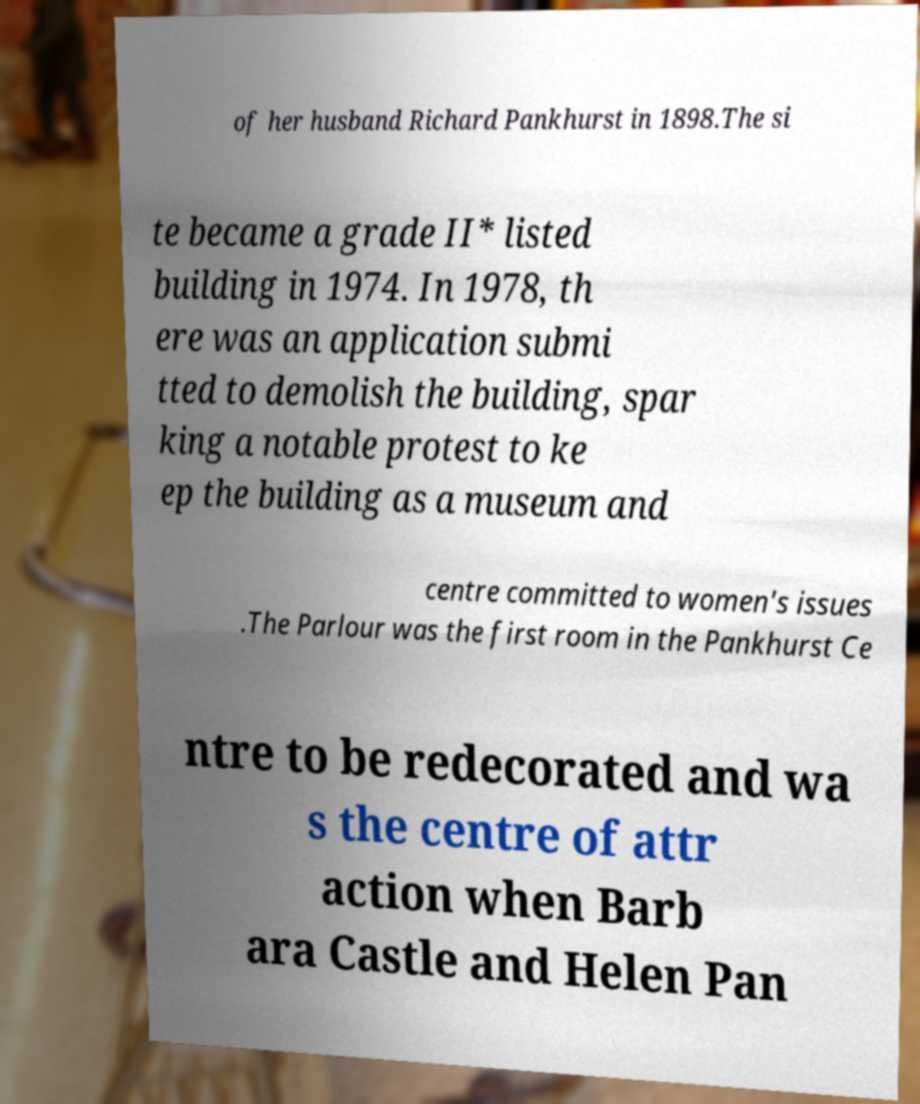For documentation purposes, I need the text within this image transcribed. Could you provide that? of her husband Richard Pankhurst in 1898.The si te became a grade II* listed building in 1974. In 1978, th ere was an application submi tted to demolish the building, spar king a notable protest to ke ep the building as a museum and centre committed to women's issues .The Parlour was the first room in the Pankhurst Ce ntre to be redecorated and wa s the centre of attr action when Barb ara Castle and Helen Pan 